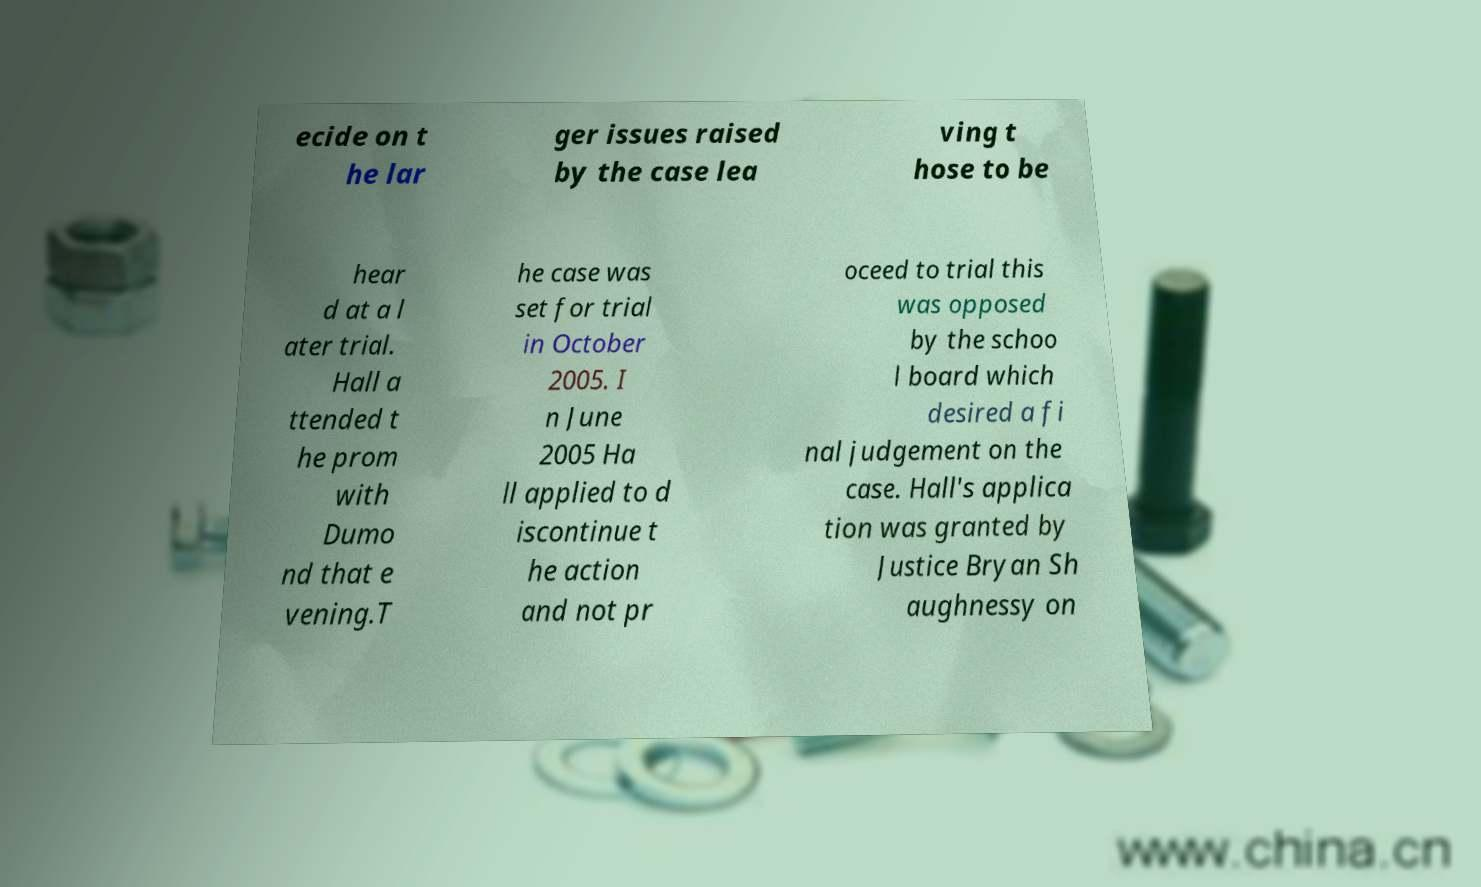Could you assist in decoding the text presented in this image and type it out clearly? ecide on t he lar ger issues raised by the case lea ving t hose to be hear d at a l ater trial. Hall a ttended t he prom with Dumo nd that e vening.T he case was set for trial in October 2005. I n June 2005 Ha ll applied to d iscontinue t he action and not pr oceed to trial this was opposed by the schoo l board which desired a fi nal judgement on the case. Hall's applica tion was granted by Justice Bryan Sh aughnessy on 